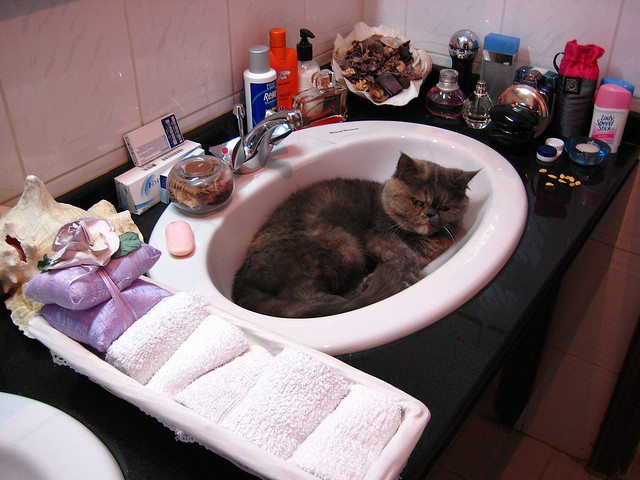Describe the objects in this image and their specific colors. I can see cat in brown, black, and maroon tones, bottle in brown, navy, gray, darkgray, and lightgray tones, bottle in brown, black, navy, gray, and maroon tones, bottle in brown, darkgray, and gray tones, and bottle in brown, red, and maroon tones in this image. 